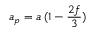Convert formula to latex. <formula><loc_0><loc_0><loc_500><loc_500>a _ { p } = a \, ( 1 - { \frac { 2 f } { 3 } } )</formula> 